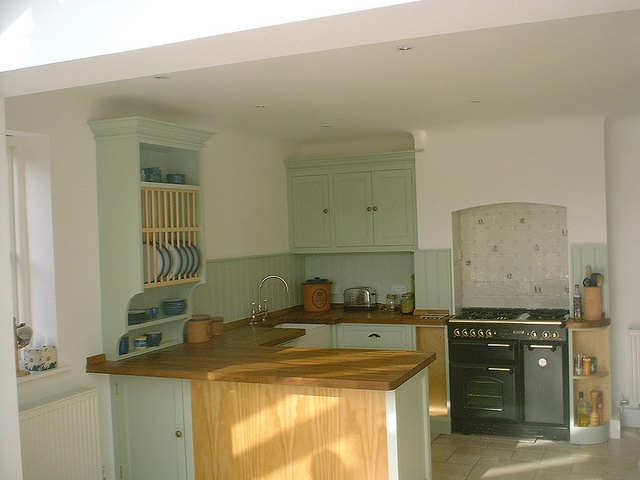Describe the objects in this image and their specific colors. I can see oven in lightgray, black, gray, and darkgreen tones, toaster in lightgray, black, darkgreen, and gray tones, bottle in lightgray and olive tones, cup in lightgray and gray tones, and sink in lightgray, gray, and black tones in this image. 